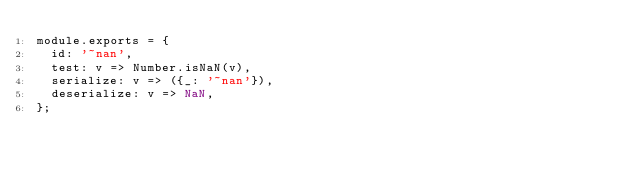<code> <loc_0><loc_0><loc_500><loc_500><_JavaScript_>module.exports = {
	id: '~nan',
	test: v => Number.isNaN(v),
	serialize: v => ({_: '~nan'}),
	deserialize: v => NaN,
};
</code> 